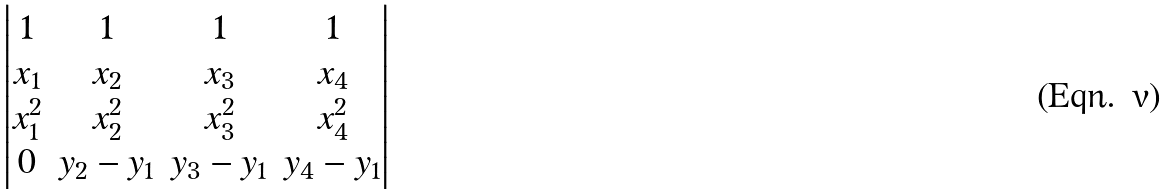<formula> <loc_0><loc_0><loc_500><loc_500>\begin{vmatrix} 1 & 1 & 1 & 1 \\ x _ { 1 } & x _ { 2 } & x _ { 3 } & x _ { 4 } \\ x _ { 1 } ^ { 2 } & x _ { 2 } ^ { 2 } & x _ { 3 } ^ { 2 } & x _ { 4 } ^ { 2 } \\ 0 & y _ { 2 } - y _ { 1 } & y _ { 3 } - y _ { 1 } & y _ { 4 } - y _ { 1 } \end{vmatrix}</formula> 